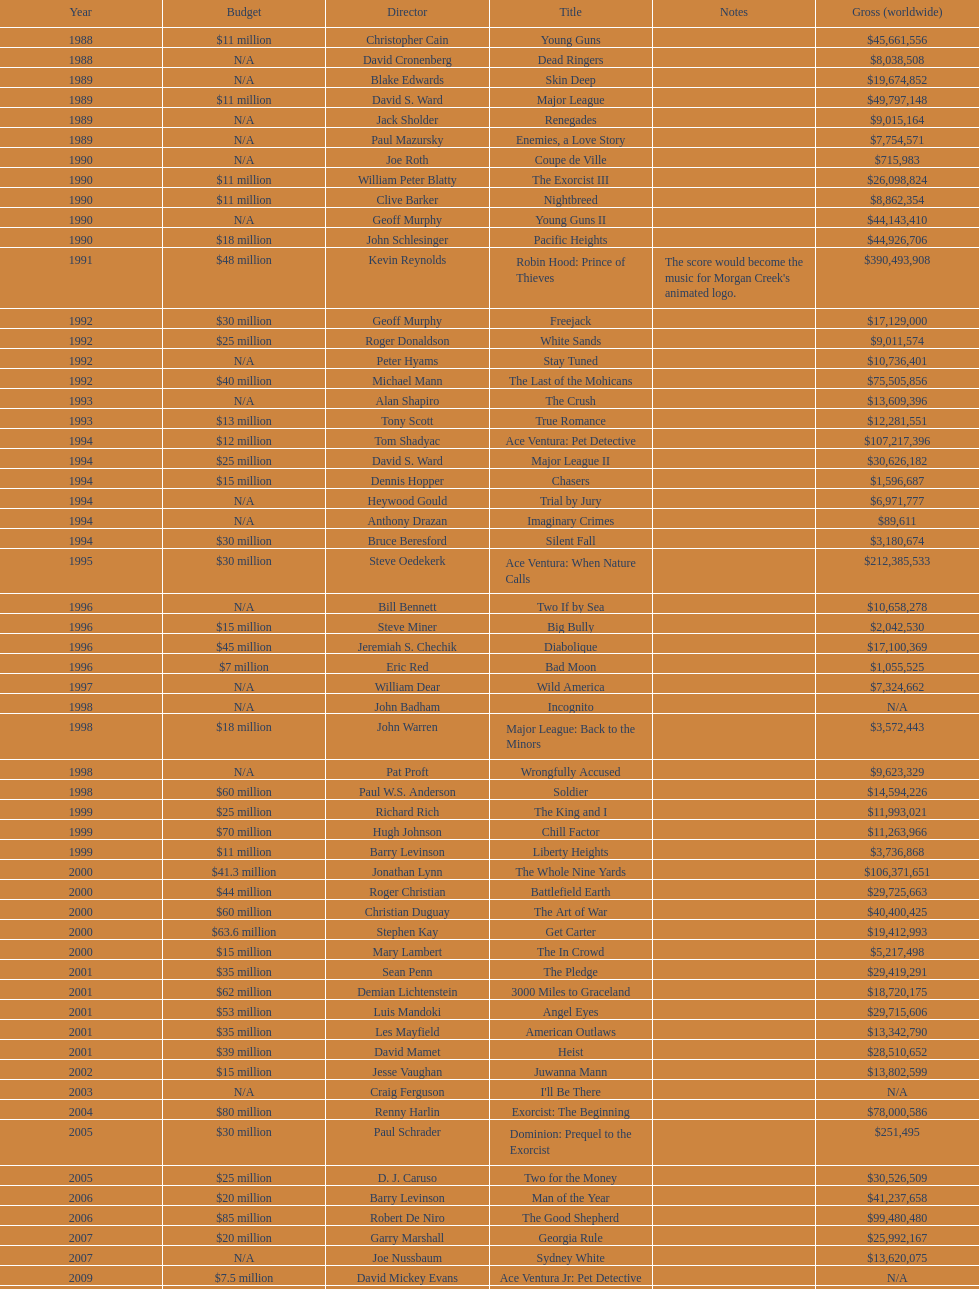What movie came out after bad moon? Wild America. 